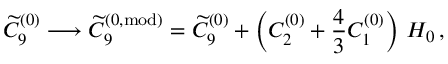<formula> <loc_0><loc_0><loc_500><loc_500>\widetilde { C } _ { 9 } ^ { ( 0 ) } \longrightarrow \widetilde { C } _ { 9 } ^ { ( 0 , m o d ) } = \widetilde { C } _ { 9 } ^ { ( 0 ) } + \left ( C _ { 2 } ^ { ( 0 ) } + \frac { 4 } { 3 } C _ { 1 } ^ { ( 0 ) } \right ) \, H _ { 0 } \, ,</formula> 